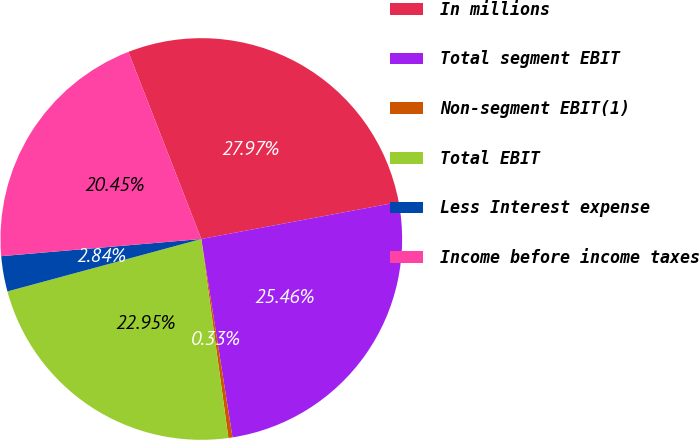<chart> <loc_0><loc_0><loc_500><loc_500><pie_chart><fcel>In millions<fcel>Total segment EBIT<fcel>Non-segment EBIT(1)<fcel>Total EBIT<fcel>Less Interest expense<fcel>Income before income taxes<nl><fcel>27.97%<fcel>25.46%<fcel>0.33%<fcel>22.95%<fcel>2.84%<fcel>20.45%<nl></chart> 